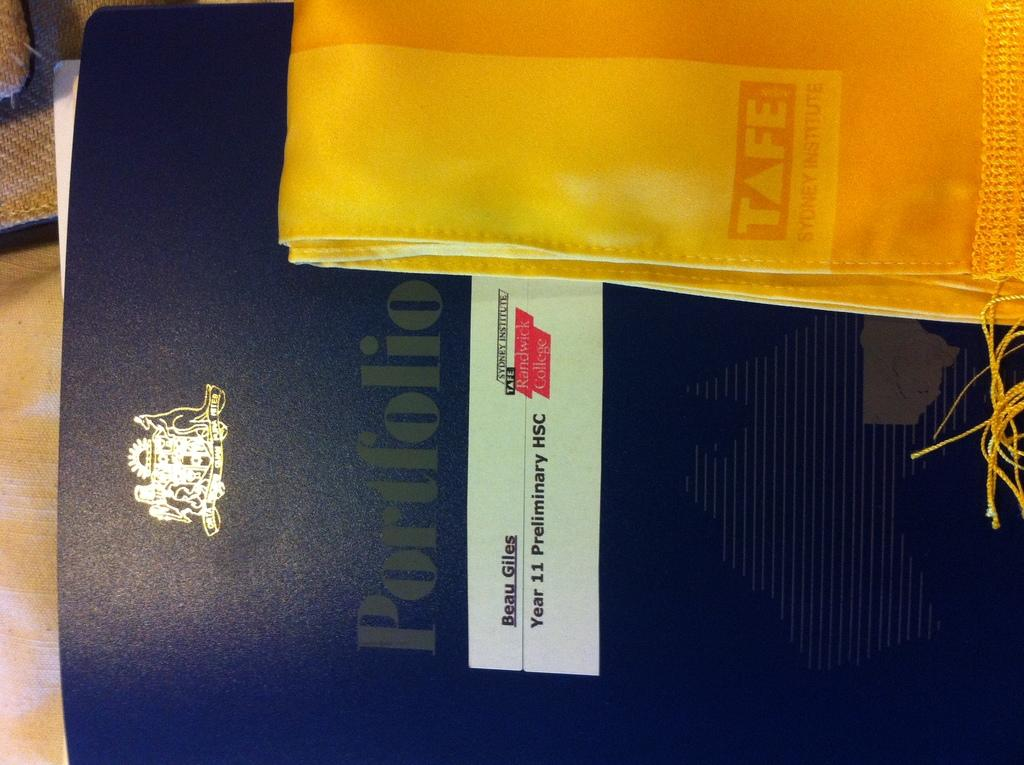<image>
Describe the image concisely. A black profolio folder labeled for a Beau Giles next to a yellow sash from TAFE Sydney Institute. 